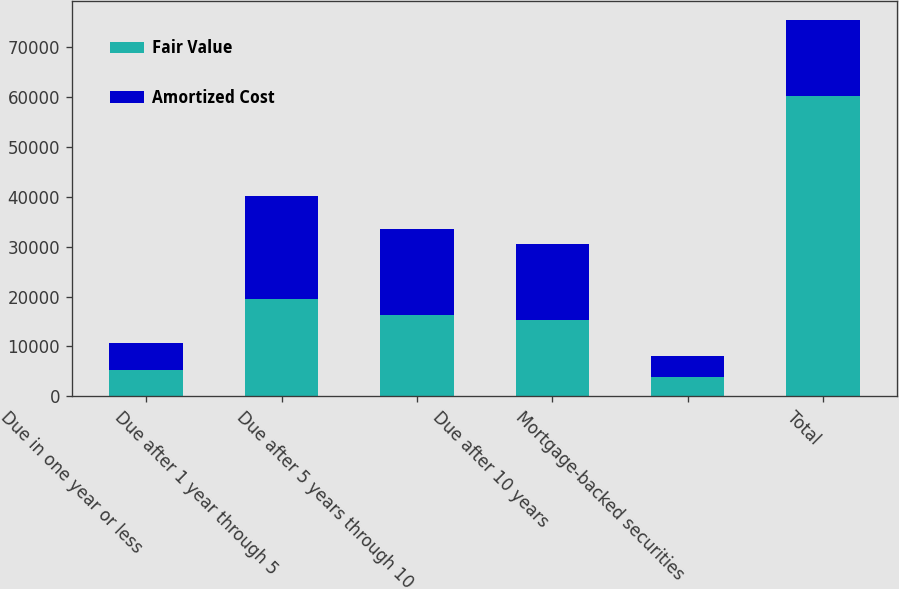Convert chart to OTSL. <chart><loc_0><loc_0><loc_500><loc_500><stacked_bar_chart><ecel><fcel>Due in one year or less<fcel>Due after 1 year through 5<fcel>Due after 5 years through 10<fcel>Due after 10 years<fcel>Mortgage-backed securities<fcel>Total<nl><fcel>Fair Value<fcel>5257<fcel>19478<fcel>16273<fcel>15210<fcel>3952<fcel>60170<nl><fcel>Amortized Cost<fcel>5340<fcel>20675<fcel>17242<fcel>15399<fcel>4164<fcel>15399<nl></chart> 